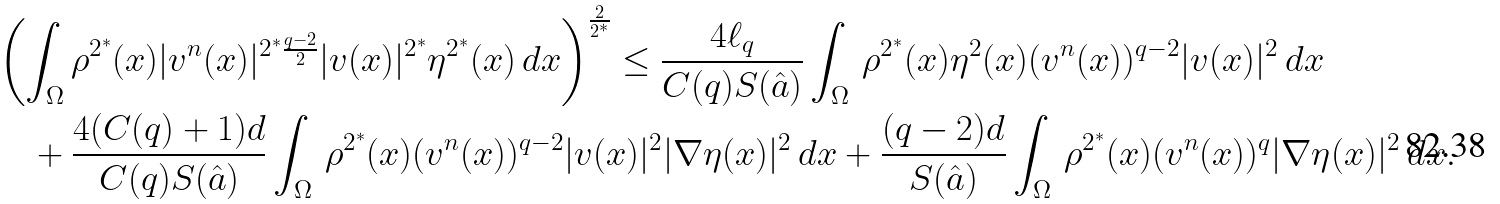Convert formula to latex. <formula><loc_0><loc_0><loc_500><loc_500>& \left ( \int _ { \Omega } \rho ^ { 2 ^ { * } } ( x ) | v ^ { n } ( x ) | ^ { 2 ^ { * } \frac { q - 2 } 2 } | v ( x ) | ^ { 2 ^ { * } } \eta ^ { 2 ^ { * } } ( x ) \, d x \right ) ^ { \frac { 2 } { 2 ^ { * } } } \leq \frac { 4 \ell _ { q } } { C ( q ) S ( \hat { a } ) } \int _ { \Omega } \, \rho ^ { 2 ^ { * } } ( x ) \eta ^ { 2 } ( x ) ( v ^ { n } ( x ) ) ^ { q - 2 } | v ( x ) | ^ { 2 } \, d x \\ & \quad + \frac { 4 ( C ( q ) + 1 ) d } { C ( q ) S ( \hat { a } ) } \int _ { \Omega } \, \rho ^ { 2 ^ { * } } ( x ) ( v ^ { n } ( x ) ) ^ { q - 2 } | v ( x ) | ^ { 2 } | \nabla \eta ( x ) | ^ { 2 } \, d x + \frac { ( q - 2 ) d } { S ( \hat { a } ) } \int _ { \Omega } \, \rho ^ { 2 ^ { * } } ( x ) ( v ^ { n } ( x ) ) ^ { q } | \nabla \eta ( x ) | ^ { 2 } \, d x .</formula> 